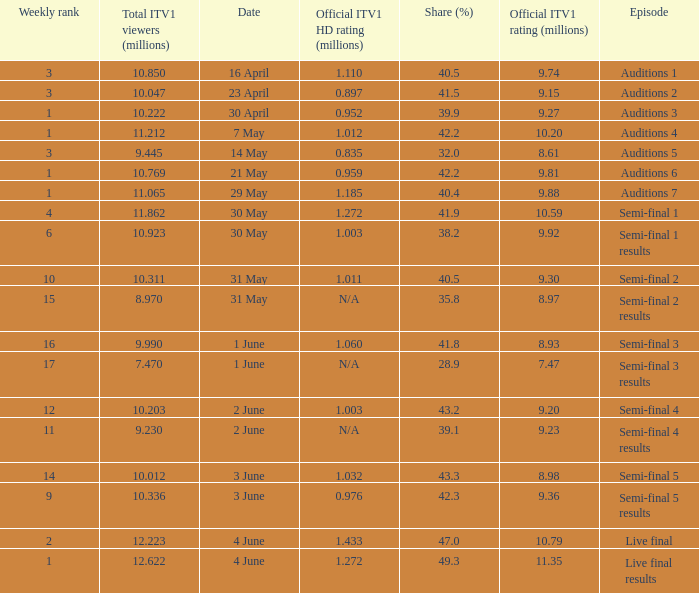Which episode had an official ITV1 HD rating of 1.185 million?  Auditions 7. 